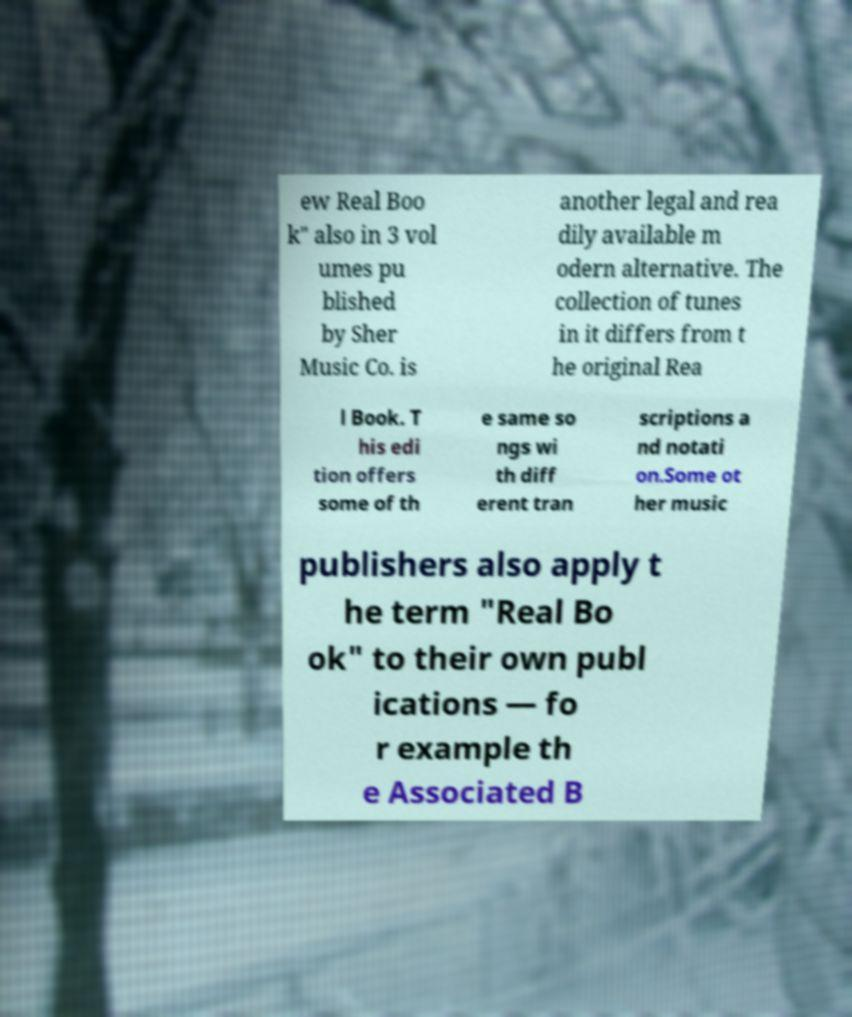I need the written content from this picture converted into text. Can you do that? ew Real Boo k" also in 3 vol umes pu blished by Sher Music Co. is another legal and rea dily available m odern alternative. The collection of tunes in it differs from t he original Rea l Book. T his edi tion offers some of th e same so ngs wi th diff erent tran scriptions a nd notati on.Some ot her music publishers also apply t he term "Real Bo ok" to their own publ ications — fo r example th e Associated B 